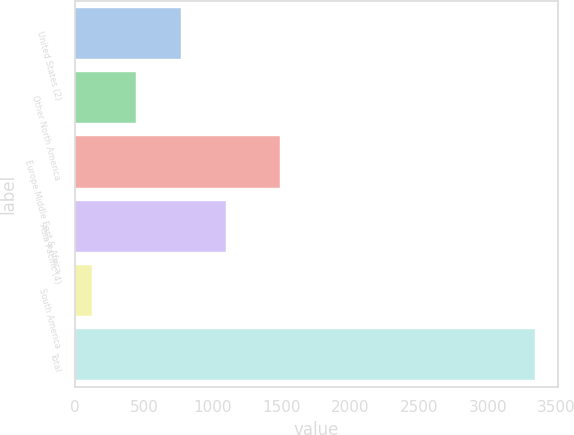Convert chart to OTSL. <chart><loc_0><loc_0><loc_500><loc_500><bar_chart><fcel>United States (2)<fcel>Other North America<fcel>Europe Middle East & Africa<fcel>Asia Pacific (4)<fcel>South America<fcel>Total<nl><fcel>772<fcel>444.1<fcel>1487<fcel>1094.1<fcel>122<fcel>3343<nl></chart> 